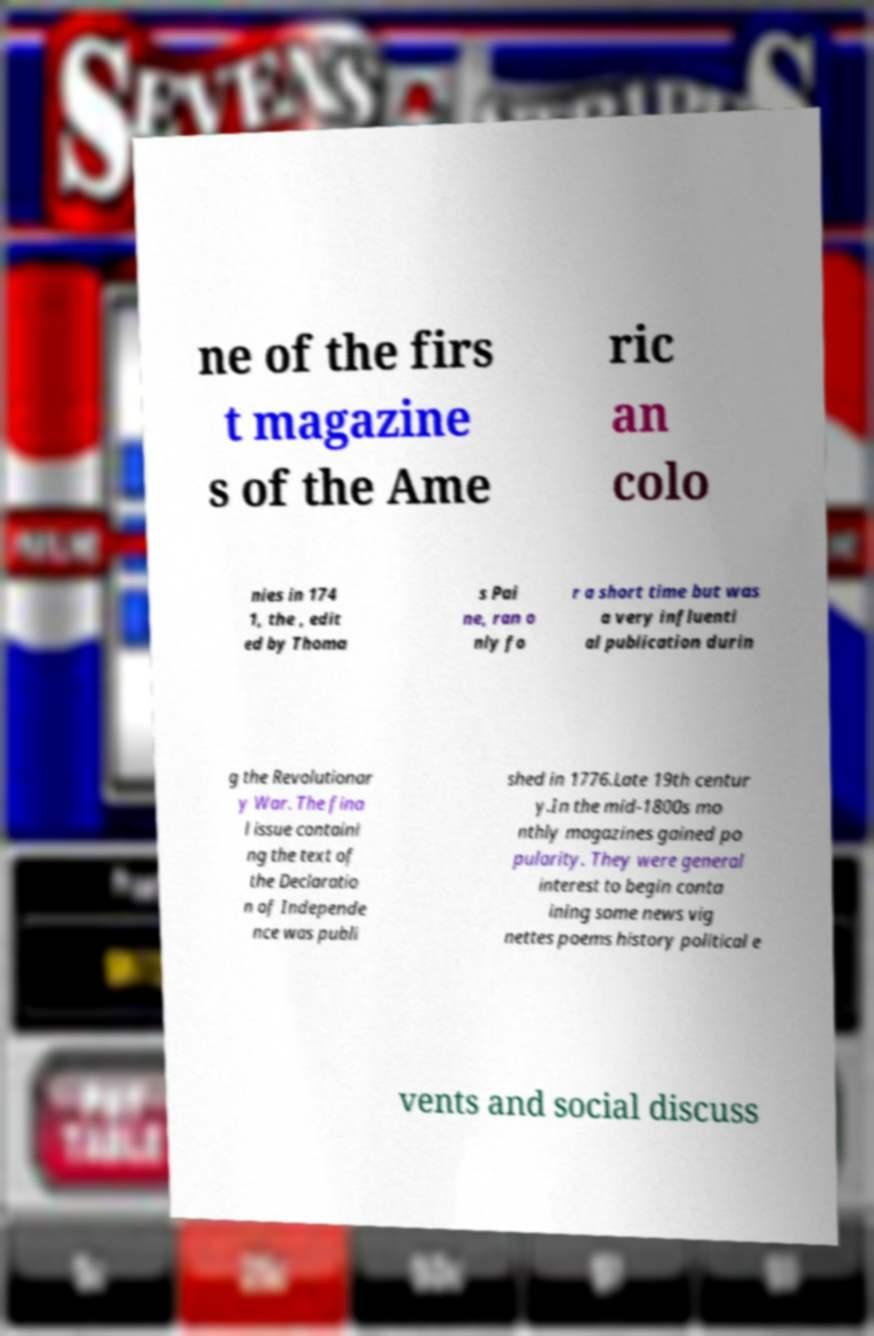Could you assist in decoding the text presented in this image and type it out clearly? ne of the firs t magazine s of the Ame ric an colo nies in 174 1, the , edit ed by Thoma s Pai ne, ran o nly fo r a short time but was a very influenti al publication durin g the Revolutionar y War. The fina l issue containi ng the text of the Declaratio n of Independe nce was publi shed in 1776.Late 19th centur y.In the mid-1800s mo nthly magazines gained po pularity. They were general interest to begin conta ining some news vig nettes poems history political e vents and social discuss 